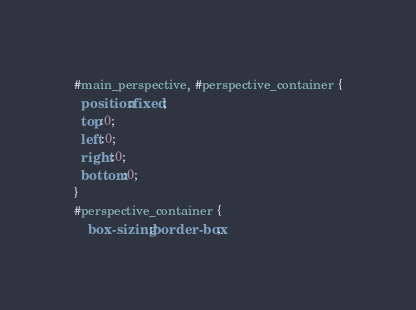<code> <loc_0><loc_0><loc_500><loc_500><_CSS_>#main_perspective, #perspective_container {
  position:fixed;
  top:0;
  left:0;
  right:0;
  bottom:0;
}
#perspective_container {
    box-sizing:border-box;</code> 